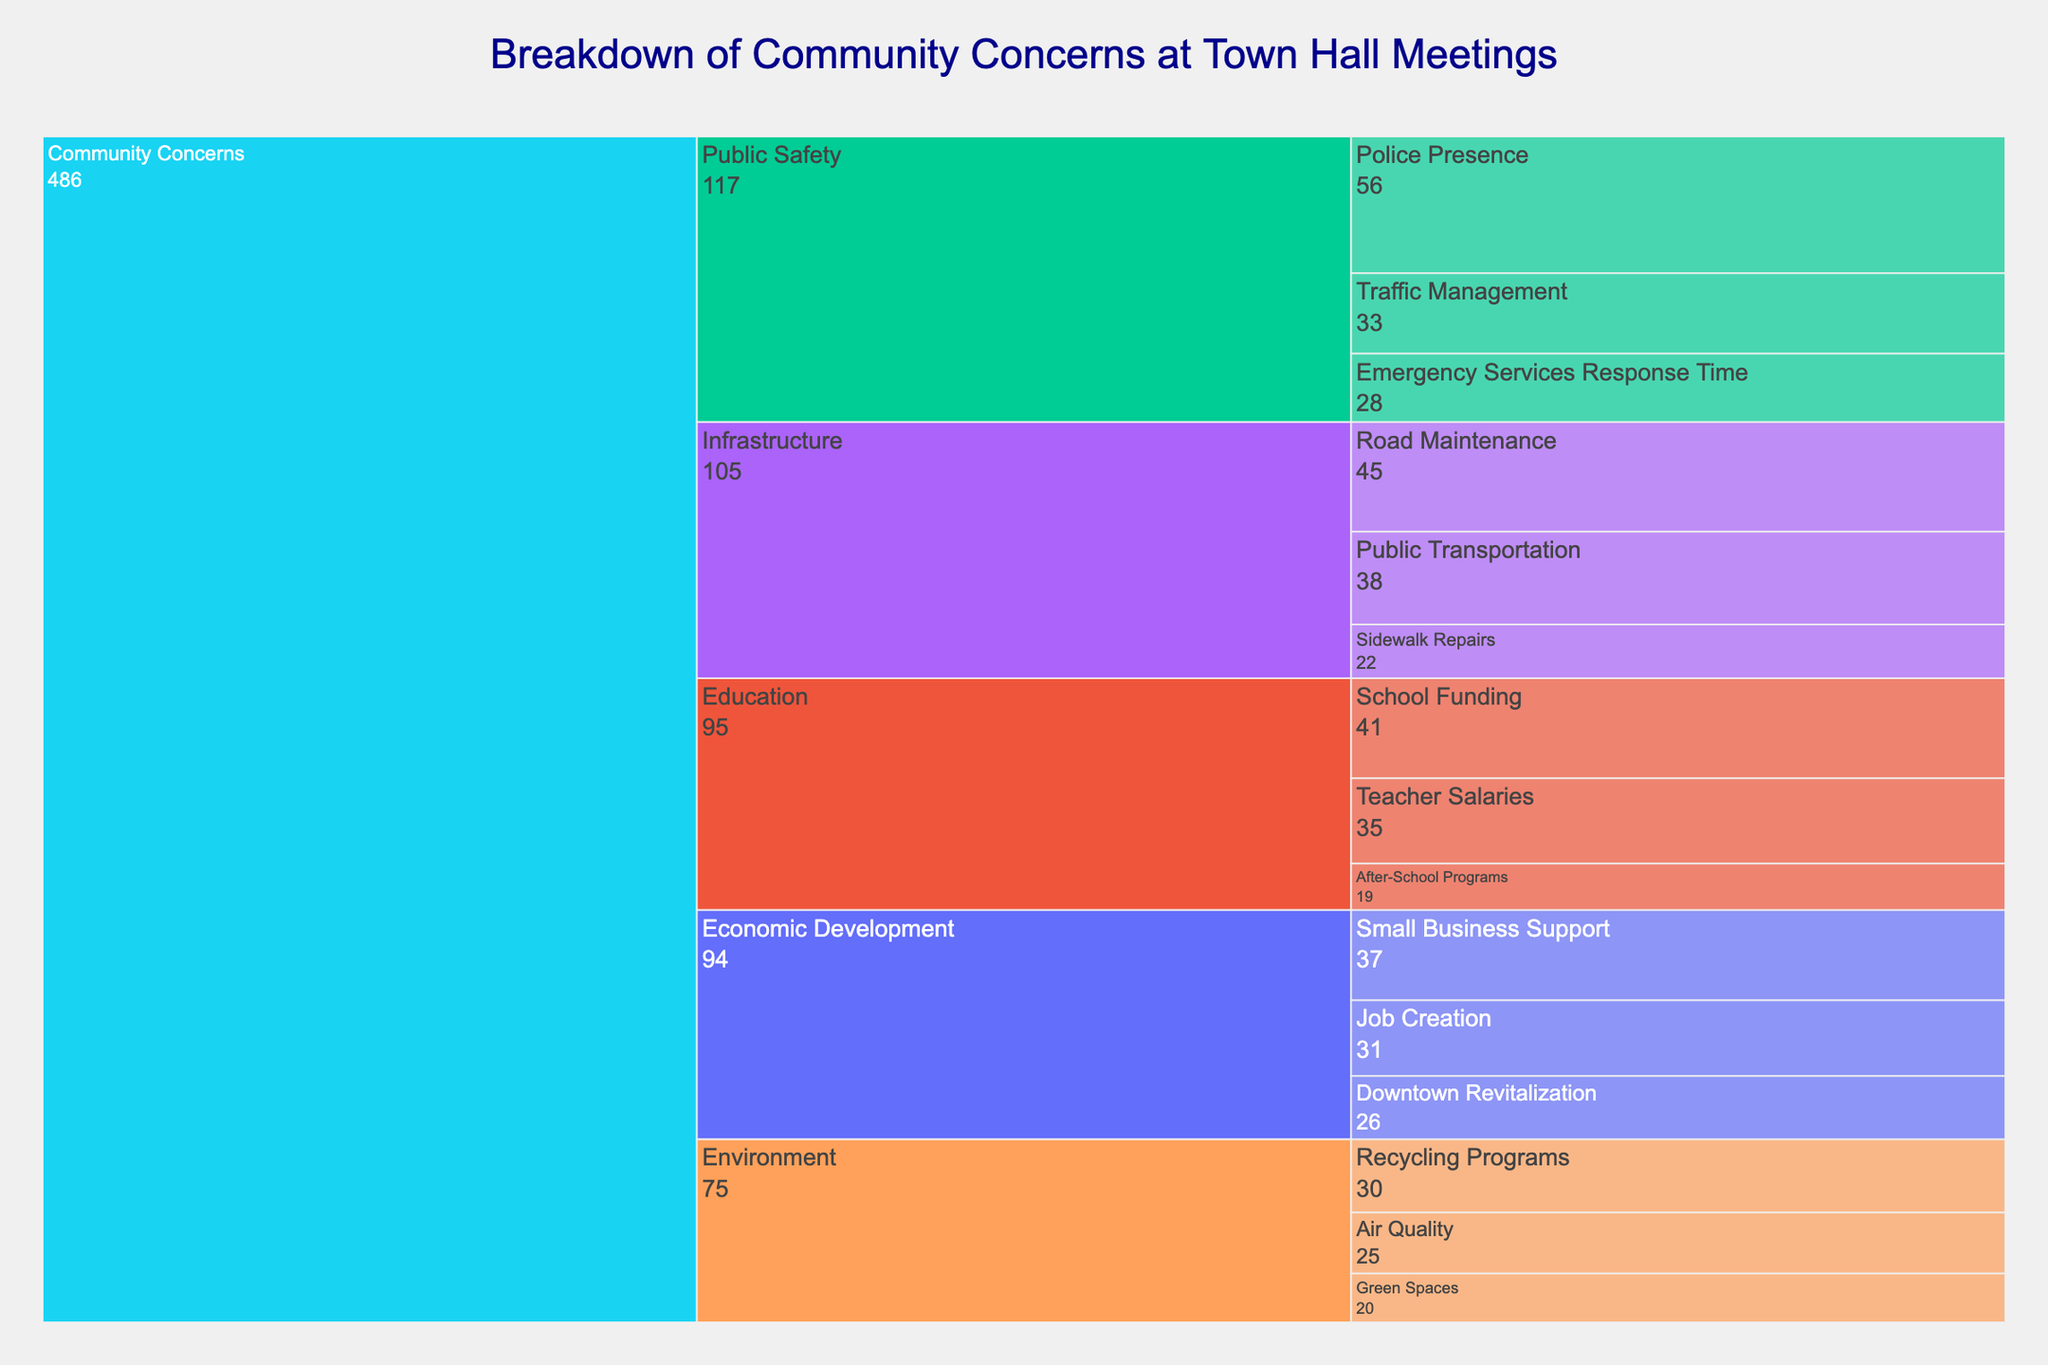What is the total number of concerns related to Infrastructure? To find the total number of concerns related to Infrastructure, sum up the counts for all sub-issues under Infrastructure. These counts are 45 (Road Maintenance) + 38 (Public Transportation) + 22 (Sidewalk Repairs).
Answer: 105 What sub-issue has the highest count under Public Safety? To identify the sub-issue with the highest count under Public Safety, compare the counts of all sub-issues under this issue. Police Presence has 56, Traffic Management has 33, and Emergency Services Response Time has 28.
Answer: Police Presence Which issue has received the least number of concerns? To find the issue with the least number of concerns, sum the counts for each main issue and compare them. Infrastructure has 105, Public Safety has 117, Education has 95, Environment has 75, and Economic Development has 94. So, Environment has the least concerns.
Answer: Environment How many more concerns are there about Teacher Salaries than After-School Programs? To find the difference between concerns about Teacher Salaries and After-School Programs, subtract the count of After-School Programs from the count of Teacher Salaries. Teacher Salaries have 35 and After-School Programs have 19. The difference is 35 - 19.
Answer: 16 What is the average count of concerns under Economic Development? To find the average count of concerns under Economic Development, sum the counts for all sub-issues under this issue and divide by the number of sub-issues. The counts are 37 (Small Business Support) + 31 (Job Creation) + 26 (Downtown Revitalization). The sum is 94, and there are 3 sub-issues, so the average is 94 / 3.
Answer: 31.33 Which sub-issue has the lowest count under Environment? To find the sub-issue with the lowest count under Environment, compare the counts of all sub-issues under this issue. Recycling Programs has 30, Air Quality has 25, and Green Spaces has 20.
Answer: Green Spaces What is the total number of concerns raised about Public Safety and Infrastructure together? To find the combined total for Public Safety and Infrastructure, sum up the totals for each issue. Public Safety has 117, and Infrastructure has 105. The combined total is 117 + 105.
Answer: 222 How does the count of Recycling Programs compare to Job Creation? To compare the counts of Recycling Programs and Job Creation, simply check their values. Recycling Programs has 30, and Job Creation has 31, so Job Creation has 1 more concern than Recycling Programs.
Answer: Job Creation has 1 more concern What is the percentage of concerns under Education relative to the total number of concerns? To find the percentage, first calculate the total number of concerns across all issues. Then, divide the total for Education by this total and multiply by 100. The total concerns are 105 (Infrastructure) + 117 (Public Safety) + 95 (Education) + 75 (Environment) + 94 (Economic Development) = 486. The percentage is (95 / 486) * 100%.
Answer: 19.55% Which main issue has the highest total count, and what is its total? To find which main issue has the highest count, sum the counts of all sub-issues under each main issue and compare them. Infrastructure has 105, Public Safety has 117, Education has 95, Environment has 75, and Economic Development has 94.
Answer: Public Safety, 117 